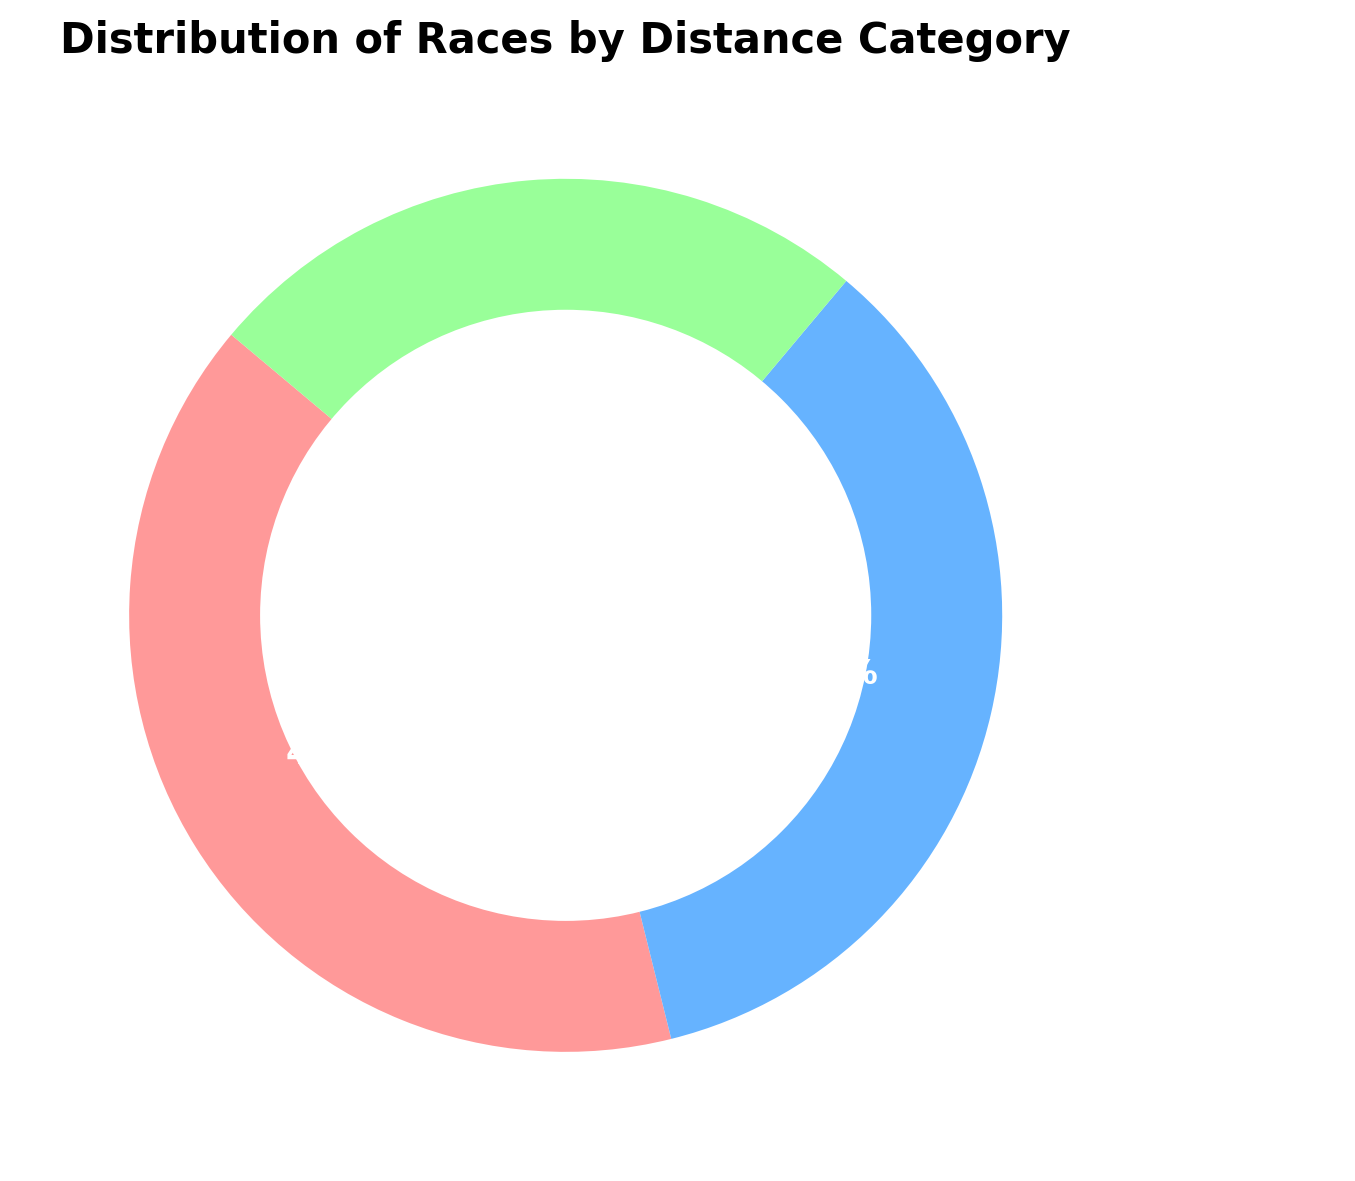How many percentages of the races are classified as Sprint or Middle Distance combined? To find the combined percentage of Sprint and Middle Distance races, add their respective percentages: Sprint (40%) + Middle Distance (35%) = 75%
Answer: 75% What is the difference in percentage between Sprint and Long Distance races? Subtract the percentage of Long Distance races from the percentage of Sprint races: Sprint (40%) - Long Distance (25%) = 15%
Answer: 15% Which distance category comprises the smallest proportion of races? By looking at the percentages for each category, the Long Distance category has the smallest proportion with 25%
Answer: Long Distance Between Sprint and Middle Distance, which category has a higher percentage, and by how much? Compare the percentage of Sprint (40%) with Middle Distance (35%). Sprint has a higher percentage by 5% (40% - 35% = 5%)
Answer: Sprint, by 5% What percentage of the races are not Long Distance? To find the percentage of races that are not Long Distance, subtract the Long Distance percentage from 100%: 100% - 25% = 75%
Answer: 75% Which category is represented using green in the plot? From the color description, the green shade is used for Middle Distance category
Answer: Middle Distance If we were to equally distribute any new races among the three categories, what would be the new percentage for each category if 15 new races were added equally? First, calculate the total percentage to be added: 15 races equally distributed among 3 categories means each category receives 5% (15 / 3). Add this to the existing percentages: Sprint (40% + 5% = 45%), Middle Distance (35% + 5% = 40%), Long Distance (25% + 5% = 30%)
Answer: Sprint 45%, Middle Distance 40%, Long Distance 30% Identify the category represented by the red color in the plot. According to the color description, the red shade is used for the Sprint category
Answer: Sprint What is the average percentage for the three distance categories? To find the average percentage, sum the percentages and divide by the number of categories: (40% + 35% + 25%) / 3 = 100% / 3 = 33.33%
Answer: 33.33% Compare Sprint and Middle Distance categories in terms of their total contribution to the distribution. Sum the percentages for Sprint and Middle Distance: Sprint (40%) + Middle Distance (35%) = 75%. Both categories together contribute 75% to the distribution
Answer: 75% 